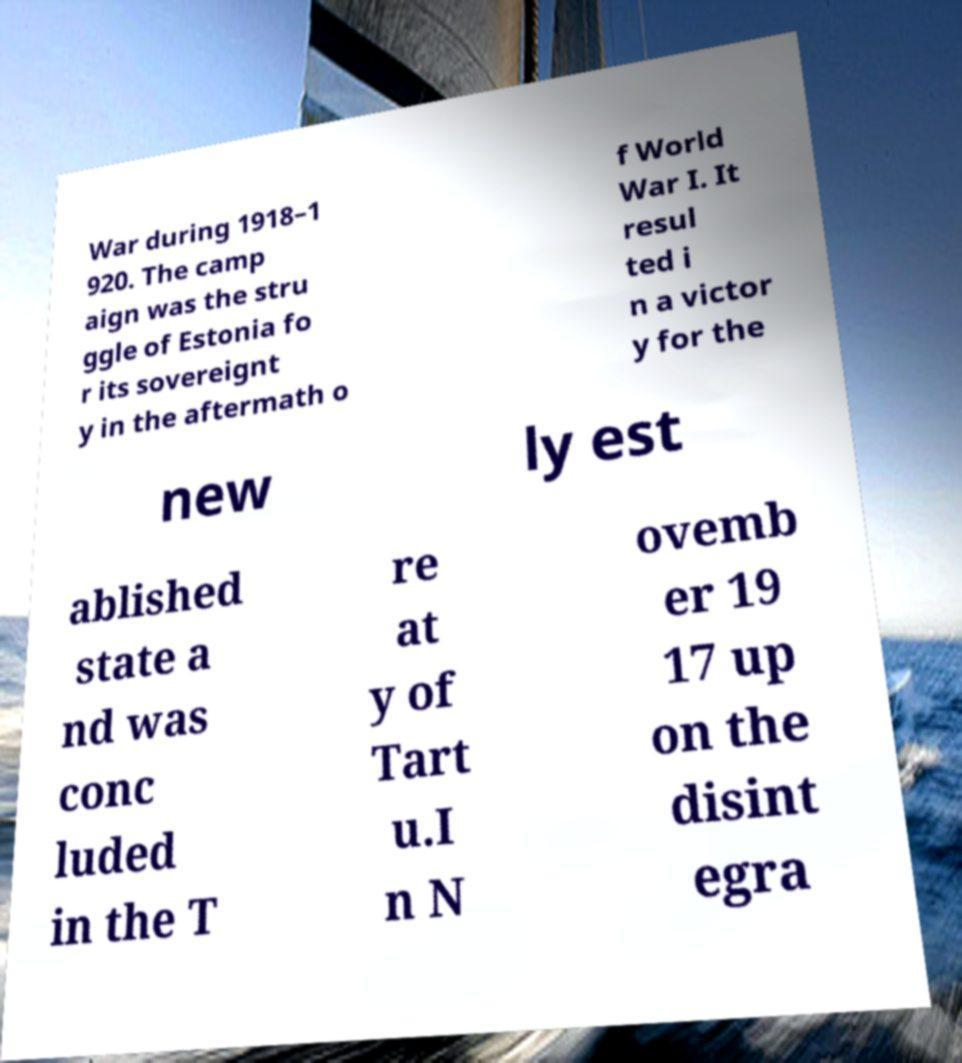Please read and relay the text visible in this image. What does it say? War during 1918–1 920. The camp aign was the stru ggle of Estonia fo r its sovereignt y in the aftermath o f World War I. It resul ted i n a victor y for the new ly est ablished state a nd was conc luded in the T re at y of Tart u.I n N ovemb er 19 17 up on the disint egra 